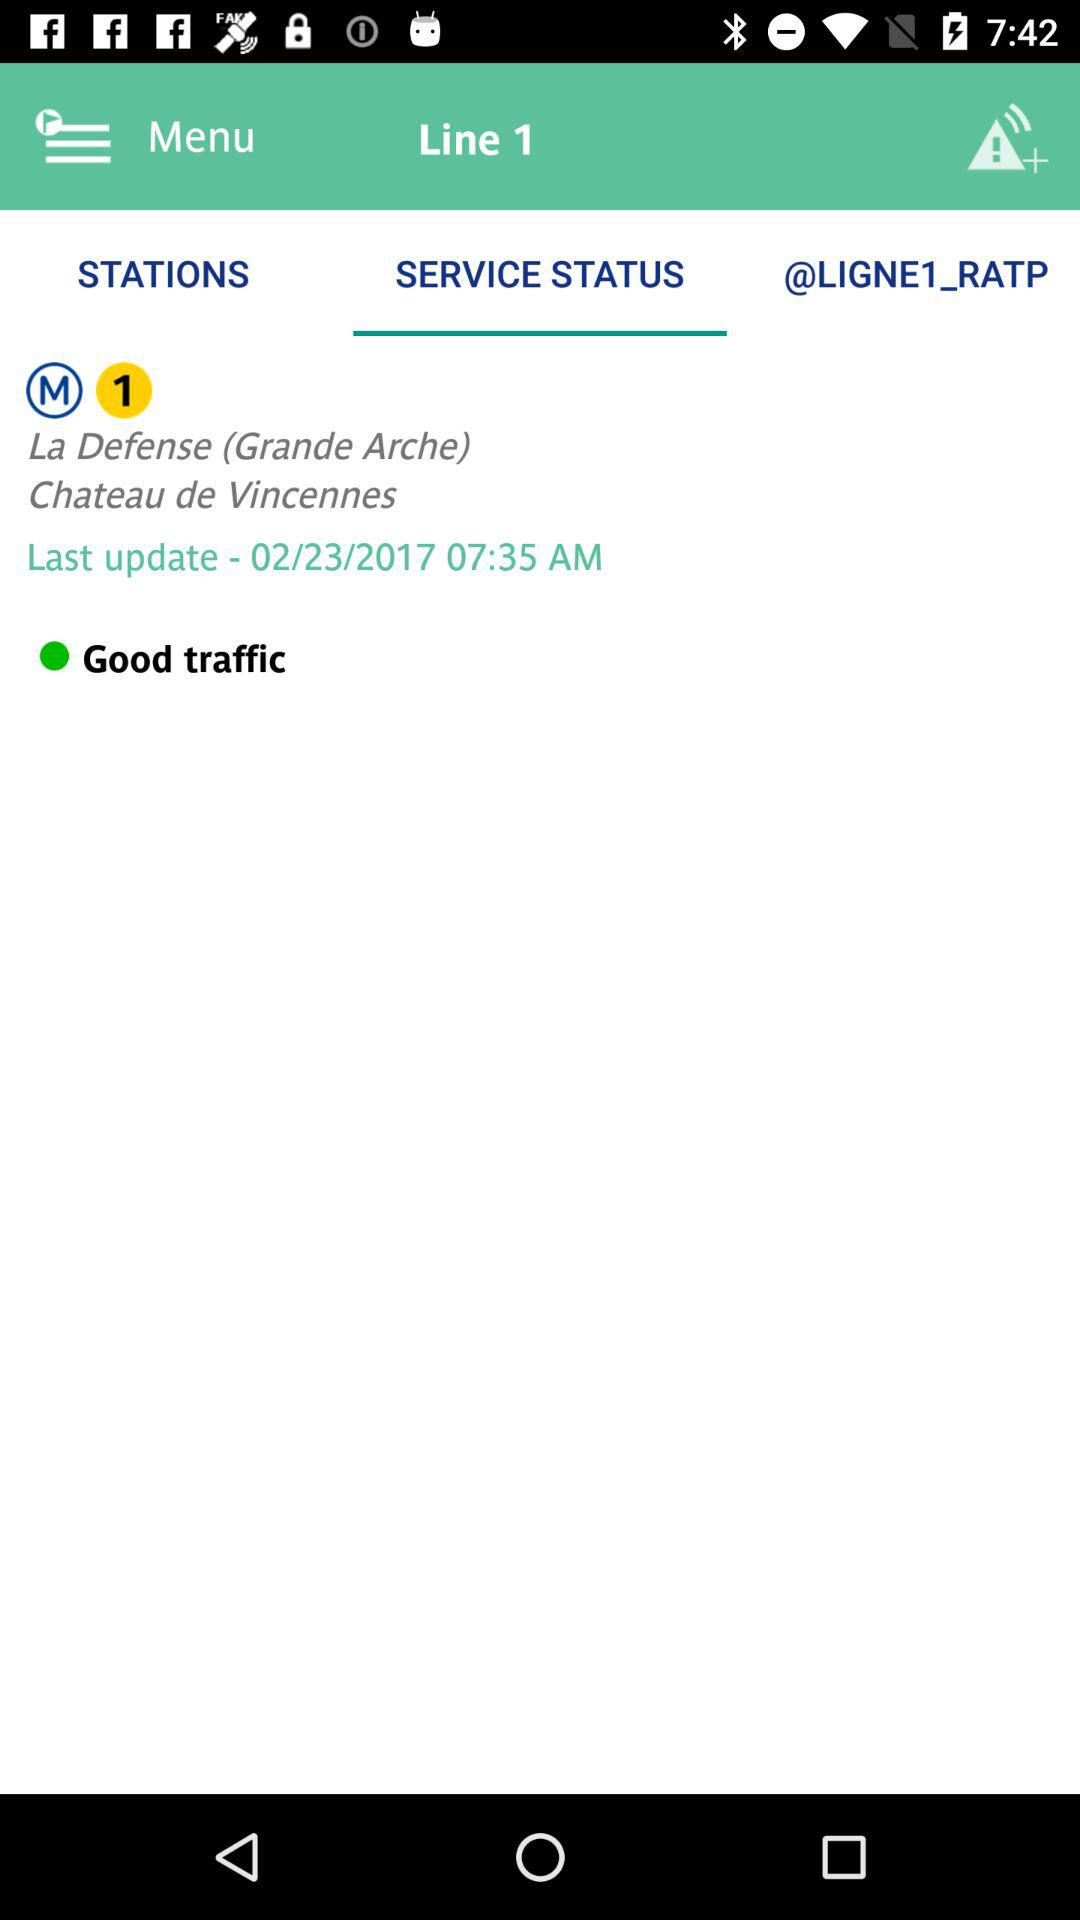Which option is selected? The selected option is "SERVICE STATUS". 